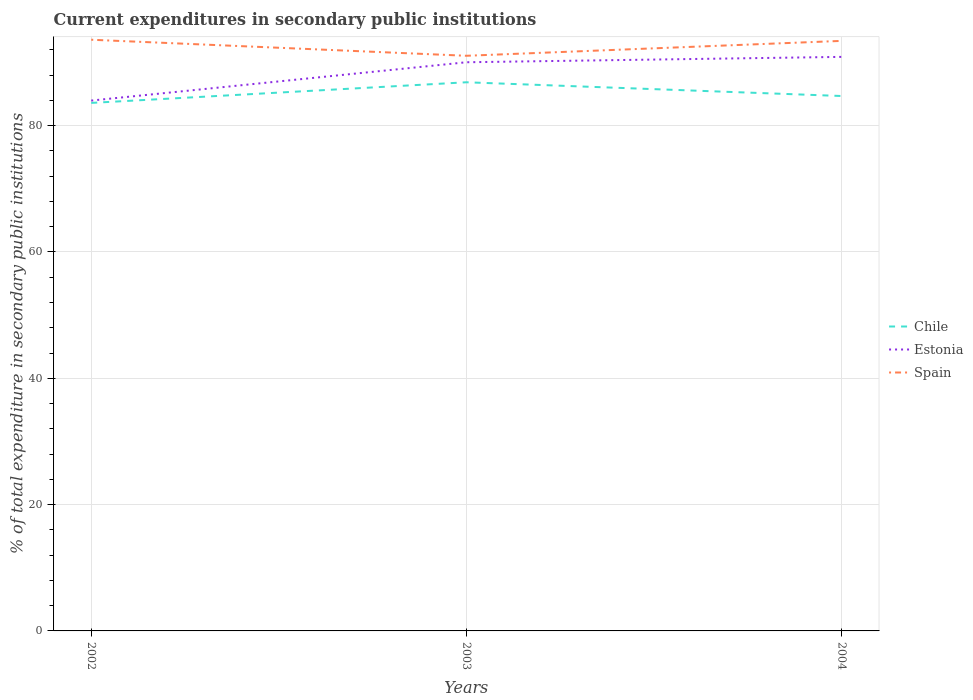Across all years, what is the maximum current expenditures in secondary public institutions in Chile?
Give a very brief answer. 83.6. What is the total current expenditures in secondary public institutions in Spain in the graph?
Your answer should be very brief. -2.36. What is the difference between the highest and the second highest current expenditures in secondary public institutions in Chile?
Provide a succinct answer. 3.27. What is the difference between the highest and the lowest current expenditures in secondary public institutions in Spain?
Give a very brief answer. 2. Is the current expenditures in secondary public institutions in Estonia strictly greater than the current expenditures in secondary public institutions in Chile over the years?
Keep it short and to the point. No. What is the difference between two consecutive major ticks on the Y-axis?
Your response must be concise. 20. Are the values on the major ticks of Y-axis written in scientific E-notation?
Make the answer very short. No. Does the graph contain grids?
Provide a succinct answer. Yes. Where does the legend appear in the graph?
Give a very brief answer. Center right. How many legend labels are there?
Offer a terse response. 3. What is the title of the graph?
Ensure brevity in your answer.  Current expenditures in secondary public institutions. What is the label or title of the Y-axis?
Offer a very short reply. % of total expenditure in secondary public institutions. What is the % of total expenditure in secondary public institutions of Chile in 2002?
Make the answer very short. 83.6. What is the % of total expenditure in secondary public institutions of Estonia in 2002?
Make the answer very short. 83.97. What is the % of total expenditure in secondary public institutions of Spain in 2002?
Keep it short and to the point. 93.6. What is the % of total expenditure in secondary public institutions of Chile in 2003?
Offer a very short reply. 86.87. What is the % of total expenditure in secondary public institutions of Estonia in 2003?
Your answer should be very brief. 90.04. What is the % of total expenditure in secondary public institutions of Spain in 2003?
Give a very brief answer. 91.06. What is the % of total expenditure in secondary public institutions of Chile in 2004?
Give a very brief answer. 84.69. What is the % of total expenditure in secondary public institutions of Estonia in 2004?
Keep it short and to the point. 90.89. What is the % of total expenditure in secondary public institutions of Spain in 2004?
Your answer should be compact. 93.42. Across all years, what is the maximum % of total expenditure in secondary public institutions of Chile?
Offer a terse response. 86.87. Across all years, what is the maximum % of total expenditure in secondary public institutions in Estonia?
Offer a terse response. 90.89. Across all years, what is the maximum % of total expenditure in secondary public institutions of Spain?
Your answer should be very brief. 93.6. Across all years, what is the minimum % of total expenditure in secondary public institutions of Chile?
Ensure brevity in your answer.  83.6. Across all years, what is the minimum % of total expenditure in secondary public institutions of Estonia?
Offer a very short reply. 83.97. Across all years, what is the minimum % of total expenditure in secondary public institutions of Spain?
Provide a succinct answer. 91.06. What is the total % of total expenditure in secondary public institutions of Chile in the graph?
Give a very brief answer. 255.17. What is the total % of total expenditure in secondary public institutions of Estonia in the graph?
Your response must be concise. 264.9. What is the total % of total expenditure in secondary public institutions of Spain in the graph?
Keep it short and to the point. 278.09. What is the difference between the % of total expenditure in secondary public institutions in Chile in 2002 and that in 2003?
Provide a short and direct response. -3.27. What is the difference between the % of total expenditure in secondary public institutions of Estonia in 2002 and that in 2003?
Keep it short and to the point. -6.07. What is the difference between the % of total expenditure in secondary public institutions in Spain in 2002 and that in 2003?
Your answer should be very brief. 2.54. What is the difference between the % of total expenditure in secondary public institutions of Chile in 2002 and that in 2004?
Give a very brief answer. -1.09. What is the difference between the % of total expenditure in secondary public institutions of Estonia in 2002 and that in 2004?
Ensure brevity in your answer.  -6.92. What is the difference between the % of total expenditure in secondary public institutions in Spain in 2002 and that in 2004?
Offer a very short reply. 0.18. What is the difference between the % of total expenditure in secondary public institutions of Chile in 2003 and that in 2004?
Keep it short and to the point. 2.17. What is the difference between the % of total expenditure in secondary public institutions in Estonia in 2003 and that in 2004?
Make the answer very short. -0.85. What is the difference between the % of total expenditure in secondary public institutions in Spain in 2003 and that in 2004?
Make the answer very short. -2.36. What is the difference between the % of total expenditure in secondary public institutions in Chile in 2002 and the % of total expenditure in secondary public institutions in Estonia in 2003?
Your answer should be very brief. -6.44. What is the difference between the % of total expenditure in secondary public institutions of Chile in 2002 and the % of total expenditure in secondary public institutions of Spain in 2003?
Your answer should be compact. -7.46. What is the difference between the % of total expenditure in secondary public institutions in Estonia in 2002 and the % of total expenditure in secondary public institutions in Spain in 2003?
Keep it short and to the point. -7.09. What is the difference between the % of total expenditure in secondary public institutions in Chile in 2002 and the % of total expenditure in secondary public institutions in Estonia in 2004?
Provide a short and direct response. -7.29. What is the difference between the % of total expenditure in secondary public institutions of Chile in 2002 and the % of total expenditure in secondary public institutions of Spain in 2004?
Offer a very short reply. -9.82. What is the difference between the % of total expenditure in secondary public institutions of Estonia in 2002 and the % of total expenditure in secondary public institutions of Spain in 2004?
Provide a succinct answer. -9.45. What is the difference between the % of total expenditure in secondary public institutions in Chile in 2003 and the % of total expenditure in secondary public institutions in Estonia in 2004?
Make the answer very short. -4.02. What is the difference between the % of total expenditure in secondary public institutions of Chile in 2003 and the % of total expenditure in secondary public institutions of Spain in 2004?
Make the answer very short. -6.55. What is the difference between the % of total expenditure in secondary public institutions in Estonia in 2003 and the % of total expenditure in secondary public institutions in Spain in 2004?
Offer a terse response. -3.38. What is the average % of total expenditure in secondary public institutions in Chile per year?
Ensure brevity in your answer.  85.06. What is the average % of total expenditure in secondary public institutions of Estonia per year?
Make the answer very short. 88.3. What is the average % of total expenditure in secondary public institutions of Spain per year?
Your answer should be very brief. 92.7. In the year 2002, what is the difference between the % of total expenditure in secondary public institutions of Chile and % of total expenditure in secondary public institutions of Estonia?
Your answer should be very brief. -0.37. In the year 2002, what is the difference between the % of total expenditure in secondary public institutions of Chile and % of total expenditure in secondary public institutions of Spain?
Your response must be concise. -10. In the year 2002, what is the difference between the % of total expenditure in secondary public institutions in Estonia and % of total expenditure in secondary public institutions in Spain?
Your response must be concise. -9.63. In the year 2003, what is the difference between the % of total expenditure in secondary public institutions of Chile and % of total expenditure in secondary public institutions of Estonia?
Your answer should be compact. -3.17. In the year 2003, what is the difference between the % of total expenditure in secondary public institutions of Chile and % of total expenditure in secondary public institutions of Spain?
Give a very brief answer. -4.2. In the year 2003, what is the difference between the % of total expenditure in secondary public institutions of Estonia and % of total expenditure in secondary public institutions of Spain?
Your response must be concise. -1.03. In the year 2004, what is the difference between the % of total expenditure in secondary public institutions in Chile and % of total expenditure in secondary public institutions in Estonia?
Your answer should be compact. -6.2. In the year 2004, what is the difference between the % of total expenditure in secondary public institutions of Chile and % of total expenditure in secondary public institutions of Spain?
Give a very brief answer. -8.73. In the year 2004, what is the difference between the % of total expenditure in secondary public institutions of Estonia and % of total expenditure in secondary public institutions of Spain?
Provide a short and direct response. -2.53. What is the ratio of the % of total expenditure in secondary public institutions in Chile in 2002 to that in 2003?
Ensure brevity in your answer.  0.96. What is the ratio of the % of total expenditure in secondary public institutions of Estonia in 2002 to that in 2003?
Your answer should be very brief. 0.93. What is the ratio of the % of total expenditure in secondary public institutions of Spain in 2002 to that in 2003?
Your answer should be very brief. 1.03. What is the ratio of the % of total expenditure in secondary public institutions of Chile in 2002 to that in 2004?
Offer a terse response. 0.99. What is the ratio of the % of total expenditure in secondary public institutions of Estonia in 2002 to that in 2004?
Keep it short and to the point. 0.92. What is the ratio of the % of total expenditure in secondary public institutions in Chile in 2003 to that in 2004?
Offer a terse response. 1.03. What is the ratio of the % of total expenditure in secondary public institutions in Estonia in 2003 to that in 2004?
Provide a short and direct response. 0.99. What is the ratio of the % of total expenditure in secondary public institutions of Spain in 2003 to that in 2004?
Offer a very short reply. 0.97. What is the difference between the highest and the second highest % of total expenditure in secondary public institutions in Chile?
Provide a succinct answer. 2.17. What is the difference between the highest and the second highest % of total expenditure in secondary public institutions in Estonia?
Offer a terse response. 0.85. What is the difference between the highest and the second highest % of total expenditure in secondary public institutions of Spain?
Provide a succinct answer. 0.18. What is the difference between the highest and the lowest % of total expenditure in secondary public institutions of Chile?
Provide a short and direct response. 3.27. What is the difference between the highest and the lowest % of total expenditure in secondary public institutions of Estonia?
Provide a short and direct response. 6.92. What is the difference between the highest and the lowest % of total expenditure in secondary public institutions in Spain?
Your response must be concise. 2.54. 